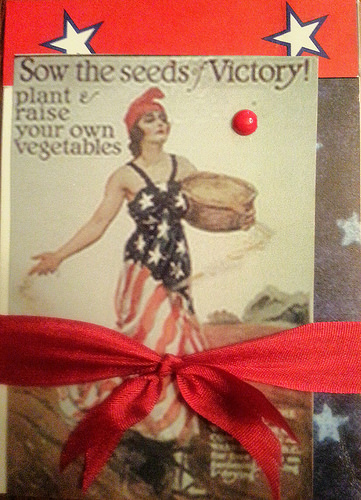<image>
Is the women in front of the basket? No. The women is not in front of the basket. The spatial positioning shows a different relationship between these objects. 